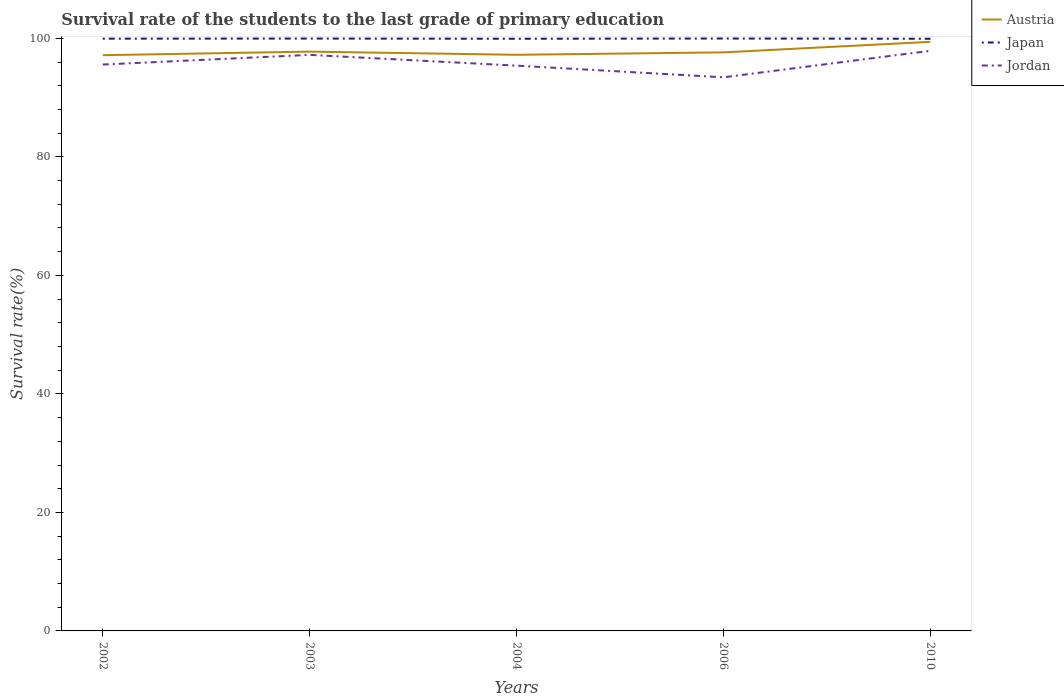Across all years, what is the maximum survival rate of the students in Japan?
Offer a very short reply. 99.93. In which year was the survival rate of the students in Japan maximum?
Give a very brief answer. 2010. What is the total survival rate of the students in Austria in the graph?
Ensure brevity in your answer.  -0.61. What is the difference between the highest and the second highest survival rate of the students in Austria?
Ensure brevity in your answer.  2.25. What is the difference between the highest and the lowest survival rate of the students in Jordan?
Keep it short and to the point. 2. Is the survival rate of the students in Japan strictly greater than the survival rate of the students in Jordan over the years?
Keep it short and to the point. No. How many years are there in the graph?
Provide a succinct answer. 5. What is the difference between two consecutive major ticks on the Y-axis?
Make the answer very short. 20. Does the graph contain any zero values?
Provide a succinct answer. No. Does the graph contain grids?
Provide a short and direct response. No. How are the legend labels stacked?
Your response must be concise. Vertical. What is the title of the graph?
Offer a very short reply. Survival rate of the students to the last grade of primary education. Does "Uganda" appear as one of the legend labels in the graph?
Provide a succinct answer. No. What is the label or title of the Y-axis?
Your answer should be very brief. Survival rate(%). What is the Survival rate(%) of Austria in 2002?
Provide a succinct answer. 97.16. What is the Survival rate(%) in Japan in 2002?
Provide a succinct answer. 99.95. What is the Survival rate(%) of Jordan in 2002?
Provide a succinct answer. 95.58. What is the Survival rate(%) in Austria in 2003?
Ensure brevity in your answer.  97.76. What is the Survival rate(%) in Japan in 2003?
Give a very brief answer. 99.97. What is the Survival rate(%) in Jordan in 2003?
Make the answer very short. 97.21. What is the Survival rate(%) in Austria in 2004?
Ensure brevity in your answer.  97.22. What is the Survival rate(%) of Japan in 2004?
Give a very brief answer. 99.93. What is the Survival rate(%) in Jordan in 2004?
Keep it short and to the point. 95.39. What is the Survival rate(%) of Austria in 2006?
Provide a short and direct response. 97.63. What is the Survival rate(%) in Japan in 2006?
Your answer should be very brief. 99.97. What is the Survival rate(%) of Jordan in 2006?
Provide a short and direct response. 93.43. What is the Survival rate(%) of Austria in 2010?
Offer a terse response. 99.41. What is the Survival rate(%) in Japan in 2010?
Make the answer very short. 99.93. What is the Survival rate(%) of Jordan in 2010?
Provide a short and direct response. 97.9. Across all years, what is the maximum Survival rate(%) of Austria?
Provide a succinct answer. 99.41. Across all years, what is the maximum Survival rate(%) in Japan?
Provide a short and direct response. 99.97. Across all years, what is the maximum Survival rate(%) of Jordan?
Provide a short and direct response. 97.9. Across all years, what is the minimum Survival rate(%) in Austria?
Offer a very short reply. 97.16. Across all years, what is the minimum Survival rate(%) in Japan?
Your answer should be very brief. 99.93. Across all years, what is the minimum Survival rate(%) in Jordan?
Your response must be concise. 93.43. What is the total Survival rate(%) of Austria in the graph?
Your answer should be very brief. 489.19. What is the total Survival rate(%) of Japan in the graph?
Provide a succinct answer. 499.75. What is the total Survival rate(%) of Jordan in the graph?
Your answer should be very brief. 479.51. What is the difference between the Survival rate(%) in Austria in 2002 and that in 2003?
Provide a short and direct response. -0.6. What is the difference between the Survival rate(%) in Japan in 2002 and that in 2003?
Offer a terse response. -0.02. What is the difference between the Survival rate(%) of Jordan in 2002 and that in 2003?
Give a very brief answer. -1.63. What is the difference between the Survival rate(%) of Austria in 2002 and that in 2004?
Your answer should be compact. -0.07. What is the difference between the Survival rate(%) in Japan in 2002 and that in 2004?
Offer a terse response. 0.01. What is the difference between the Survival rate(%) in Jordan in 2002 and that in 2004?
Make the answer very short. 0.19. What is the difference between the Survival rate(%) of Austria in 2002 and that in 2006?
Provide a succinct answer. -0.48. What is the difference between the Survival rate(%) in Japan in 2002 and that in 2006?
Provide a succinct answer. -0.03. What is the difference between the Survival rate(%) of Jordan in 2002 and that in 2006?
Offer a terse response. 2.15. What is the difference between the Survival rate(%) in Austria in 2002 and that in 2010?
Offer a very short reply. -2.25. What is the difference between the Survival rate(%) in Japan in 2002 and that in 2010?
Make the answer very short. 0.02. What is the difference between the Survival rate(%) in Jordan in 2002 and that in 2010?
Offer a very short reply. -2.32. What is the difference between the Survival rate(%) in Austria in 2003 and that in 2004?
Your response must be concise. 0.54. What is the difference between the Survival rate(%) in Japan in 2003 and that in 2004?
Ensure brevity in your answer.  0.03. What is the difference between the Survival rate(%) in Jordan in 2003 and that in 2004?
Offer a terse response. 1.82. What is the difference between the Survival rate(%) of Austria in 2003 and that in 2006?
Your response must be concise. 0.13. What is the difference between the Survival rate(%) in Japan in 2003 and that in 2006?
Ensure brevity in your answer.  -0.01. What is the difference between the Survival rate(%) in Jordan in 2003 and that in 2006?
Make the answer very short. 3.79. What is the difference between the Survival rate(%) of Austria in 2003 and that in 2010?
Offer a terse response. -1.65. What is the difference between the Survival rate(%) in Japan in 2003 and that in 2010?
Offer a very short reply. 0.04. What is the difference between the Survival rate(%) in Jordan in 2003 and that in 2010?
Offer a very short reply. -0.69. What is the difference between the Survival rate(%) of Austria in 2004 and that in 2006?
Offer a terse response. -0.41. What is the difference between the Survival rate(%) of Japan in 2004 and that in 2006?
Make the answer very short. -0.04. What is the difference between the Survival rate(%) of Jordan in 2004 and that in 2006?
Your answer should be compact. 1.97. What is the difference between the Survival rate(%) in Austria in 2004 and that in 2010?
Ensure brevity in your answer.  -2.19. What is the difference between the Survival rate(%) in Japan in 2004 and that in 2010?
Provide a succinct answer. 0. What is the difference between the Survival rate(%) of Jordan in 2004 and that in 2010?
Offer a very short reply. -2.51. What is the difference between the Survival rate(%) of Austria in 2006 and that in 2010?
Offer a very short reply. -1.78. What is the difference between the Survival rate(%) of Japan in 2006 and that in 2010?
Keep it short and to the point. 0.04. What is the difference between the Survival rate(%) of Jordan in 2006 and that in 2010?
Give a very brief answer. -4.47. What is the difference between the Survival rate(%) of Austria in 2002 and the Survival rate(%) of Japan in 2003?
Your response must be concise. -2.81. What is the difference between the Survival rate(%) of Austria in 2002 and the Survival rate(%) of Jordan in 2003?
Your answer should be compact. -0.06. What is the difference between the Survival rate(%) of Japan in 2002 and the Survival rate(%) of Jordan in 2003?
Your answer should be compact. 2.73. What is the difference between the Survival rate(%) in Austria in 2002 and the Survival rate(%) in Japan in 2004?
Provide a short and direct response. -2.78. What is the difference between the Survival rate(%) in Austria in 2002 and the Survival rate(%) in Jordan in 2004?
Your answer should be compact. 1.77. What is the difference between the Survival rate(%) of Japan in 2002 and the Survival rate(%) of Jordan in 2004?
Offer a very short reply. 4.55. What is the difference between the Survival rate(%) in Austria in 2002 and the Survival rate(%) in Japan in 2006?
Keep it short and to the point. -2.81. What is the difference between the Survival rate(%) in Austria in 2002 and the Survival rate(%) in Jordan in 2006?
Your answer should be compact. 3.73. What is the difference between the Survival rate(%) in Japan in 2002 and the Survival rate(%) in Jordan in 2006?
Offer a very short reply. 6.52. What is the difference between the Survival rate(%) of Austria in 2002 and the Survival rate(%) of Japan in 2010?
Ensure brevity in your answer.  -2.77. What is the difference between the Survival rate(%) of Austria in 2002 and the Survival rate(%) of Jordan in 2010?
Your answer should be compact. -0.74. What is the difference between the Survival rate(%) of Japan in 2002 and the Survival rate(%) of Jordan in 2010?
Give a very brief answer. 2.05. What is the difference between the Survival rate(%) of Austria in 2003 and the Survival rate(%) of Japan in 2004?
Your answer should be compact. -2.17. What is the difference between the Survival rate(%) of Austria in 2003 and the Survival rate(%) of Jordan in 2004?
Ensure brevity in your answer.  2.37. What is the difference between the Survival rate(%) in Japan in 2003 and the Survival rate(%) in Jordan in 2004?
Provide a short and direct response. 4.57. What is the difference between the Survival rate(%) of Austria in 2003 and the Survival rate(%) of Japan in 2006?
Provide a succinct answer. -2.21. What is the difference between the Survival rate(%) in Austria in 2003 and the Survival rate(%) in Jordan in 2006?
Keep it short and to the point. 4.34. What is the difference between the Survival rate(%) in Japan in 2003 and the Survival rate(%) in Jordan in 2006?
Make the answer very short. 6.54. What is the difference between the Survival rate(%) of Austria in 2003 and the Survival rate(%) of Japan in 2010?
Provide a short and direct response. -2.17. What is the difference between the Survival rate(%) of Austria in 2003 and the Survival rate(%) of Jordan in 2010?
Make the answer very short. -0.14. What is the difference between the Survival rate(%) of Japan in 2003 and the Survival rate(%) of Jordan in 2010?
Ensure brevity in your answer.  2.07. What is the difference between the Survival rate(%) of Austria in 2004 and the Survival rate(%) of Japan in 2006?
Offer a very short reply. -2.75. What is the difference between the Survival rate(%) in Austria in 2004 and the Survival rate(%) in Jordan in 2006?
Offer a very short reply. 3.8. What is the difference between the Survival rate(%) of Japan in 2004 and the Survival rate(%) of Jordan in 2006?
Keep it short and to the point. 6.51. What is the difference between the Survival rate(%) in Austria in 2004 and the Survival rate(%) in Japan in 2010?
Your answer should be compact. -2.71. What is the difference between the Survival rate(%) of Austria in 2004 and the Survival rate(%) of Jordan in 2010?
Offer a terse response. -0.67. What is the difference between the Survival rate(%) of Japan in 2004 and the Survival rate(%) of Jordan in 2010?
Offer a terse response. 2.03. What is the difference between the Survival rate(%) in Austria in 2006 and the Survival rate(%) in Japan in 2010?
Offer a very short reply. -2.3. What is the difference between the Survival rate(%) of Austria in 2006 and the Survival rate(%) of Jordan in 2010?
Offer a very short reply. -0.26. What is the difference between the Survival rate(%) in Japan in 2006 and the Survival rate(%) in Jordan in 2010?
Keep it short and to the point. 2.07. What is the average Survival rate(%) in Austria per year?
Ensure brevity in your answer.  97.84. What is the average Survival rate(%) in Japan per year?
Provide a short and direct response. 99.95. What is the average Survival rate(%) of Jordan per year?
Offer a terse response. 95.9. In the year 2002, what is the difference between the Survival rate(%) of Austria and Survival rate(%) of Japan?
Provide a short and direct response. -2.79. In the year 2002, what is the difference between the Survival rate(%) in Austria and Survival rate(%) in Jordan?
Give a very brief answer. 1.58. In the year 2002, what is the difference between the Survival rate(%) of Japan and Survival rate(%) of Jordan?
Your response must be concise. 4.37. In the year 2003, what is the difference between the Survival rate(%) in Austria and Survival rate(%) in Japan?
Keep it short and to the point. -2.2. In the year 2003, what is the difference between the Survival rate(%) of Austria and Survival rate(%) of Jordan?
Your response must be concise. 0.55. In the year 2003, what is the difference between the Survival rate(%) of Japan and Survival rate(%) of Jordan?
Offer a terse response. 2.75. In the year 2004, what is the difference between the Survival rate(%) of Austria and Survival rate(%) of Japan?
Offer a terse response. -2.71. In the year 2004, what is the difference between the Survival rate(%) in Austria and Survival rate(%) in Jordan?
Give a very brief answer. 1.83. In the year 2004, what is the difference between the Survival rate(%) of Japan and Survival rate(%) of Jordan?
Your response must be concise. 4.54. In the year 2006, what is the difference between the Survival rate(%) of Austria and Survival rate(%) of Japan?
Your answer should be very brief. -2.34. In the year 2006, what is the difference between the Survival rate(%) of Austria and Survival rate(%) of Jordan?
Your response must be concise. 4.21. In the year 2006, what is the difference between the Survival rate(%) in Japan and Survival rate(%) in Jordan?
Make the answer very short. 6.55. In the year 2010, what is the difference between the Survival rate(%) in Austria and Survival rate(%) in Japan?
Give a very brief answer. -0.52. In the year 2010, what is the difference between the Survival rate(%) in Austria and Survival rate(%) in Jordan?
Offer a very short reply. 1.51. In the year 2010, what is the difference between the Survival rate(%) of Japan and Survival rate(%) of Jordan?
Give a very brief answer. 2.03. What is the ratio of the Survival rate(%) in Japan in 2002 to that in 2003?
Offer a terse response. 1. What is the ratio of the Survival rate(%) of Jordan in 2002 to that in 2003?
Keep it short and to the point. 0.98. What is the ratio of the Survival rate(%) of Austria in 2002 to that in 2004?
Keep it short and to the point. 1. What is the ratio of the Survival rate(%) of Japan in 2002 to that in 2004?
Your answer should be very brief. 1. What is the ratio of the Survival rate(%) in Jordan in 2002 to that in 2004?
Provide a succinct answer. 1. What is the ratio of the Survival rate(%) of Austria in 2002 to that in 2006?
Provide a succinct answer. 1. What is the ratio of the Survival rate(%) in Austria in 2002 to that in 2010?
Provide a short and direct response. 0.98. What is the ratio of the Survival rate(%) in Japan in 2002 to that in 2010?
Your answer should be compact. 1. What is the ratio of the Survival rate(%) in Jordan in 2002 to that in 2010?
Keep it short and to the point. 0.98. What is the ratio of the Survival rate(%) of Japan in 2003 to that in 2004?
Your answer should be compact. 1. What is the ratio of the Survival rate(%) of Jordan in 2003 to that in 2004?
Your response must be concise. 1.02. What is the ratio of the Survival rate(%) of Austria in 2003 to that in 2006?
Offer a terse response. 1. What is the ratio of the Survival rate(%) in Jordan in 2003 to that in 2006?
Your answer should be very brief. 1.04. What is the ratio of the Survival rate(%) in Austria in 2003 to that in 2010?
Give a very brief answer. 0.98. What is the ratio of the Survival rate(%) of Japan in 2003 to that in 2010?
Keep it short and to the point. 1. What is the ratio of the Survival rate(%) of Japan in 2004 to that in 2006?
Ensure brevity in your answer.  1. What is the ratio of the Survival rate(%) in Jordan in 2004 to that in 2006?
Provide a succinct answer. 1.02. What is the ratio of the Survival rate(%) of Jordan in 2004 to that in 2010?
Ensure brevity in your answer.  0.97. What is the ratio of the Survival rate(%) of Austria in 2006 to that in 2010?
Your answer should be compact. 0.98. What is the ratio of the Survival rate(%) of Jordan in 2006 to that in 2010?
Ensure brevity in your answer.  0.95. What is the difference between the highest and the second highest Survival rate(%) of Austria?
Give a very brief answer. 1.65. What is the difference between the highest and the second highest Survival rate(%) in Japan?
Keep it short and to the point. 0.01. What is the difference between the highest and the second highest Survival rate(%) in Jordan?
Your answer should be compact. 0.69. What is the difference between the highest and the lowest Survival rate(%) of Austria?
Provide a succinct answer. 2.25. What is the difference between the highest and the lowest Survival rate(%) of Japan?
Make the answer very short. 0.04. What is the difference between the highest and the lowest Survival rate(%) of Jordan?
Your response must be concise. 4.47. 